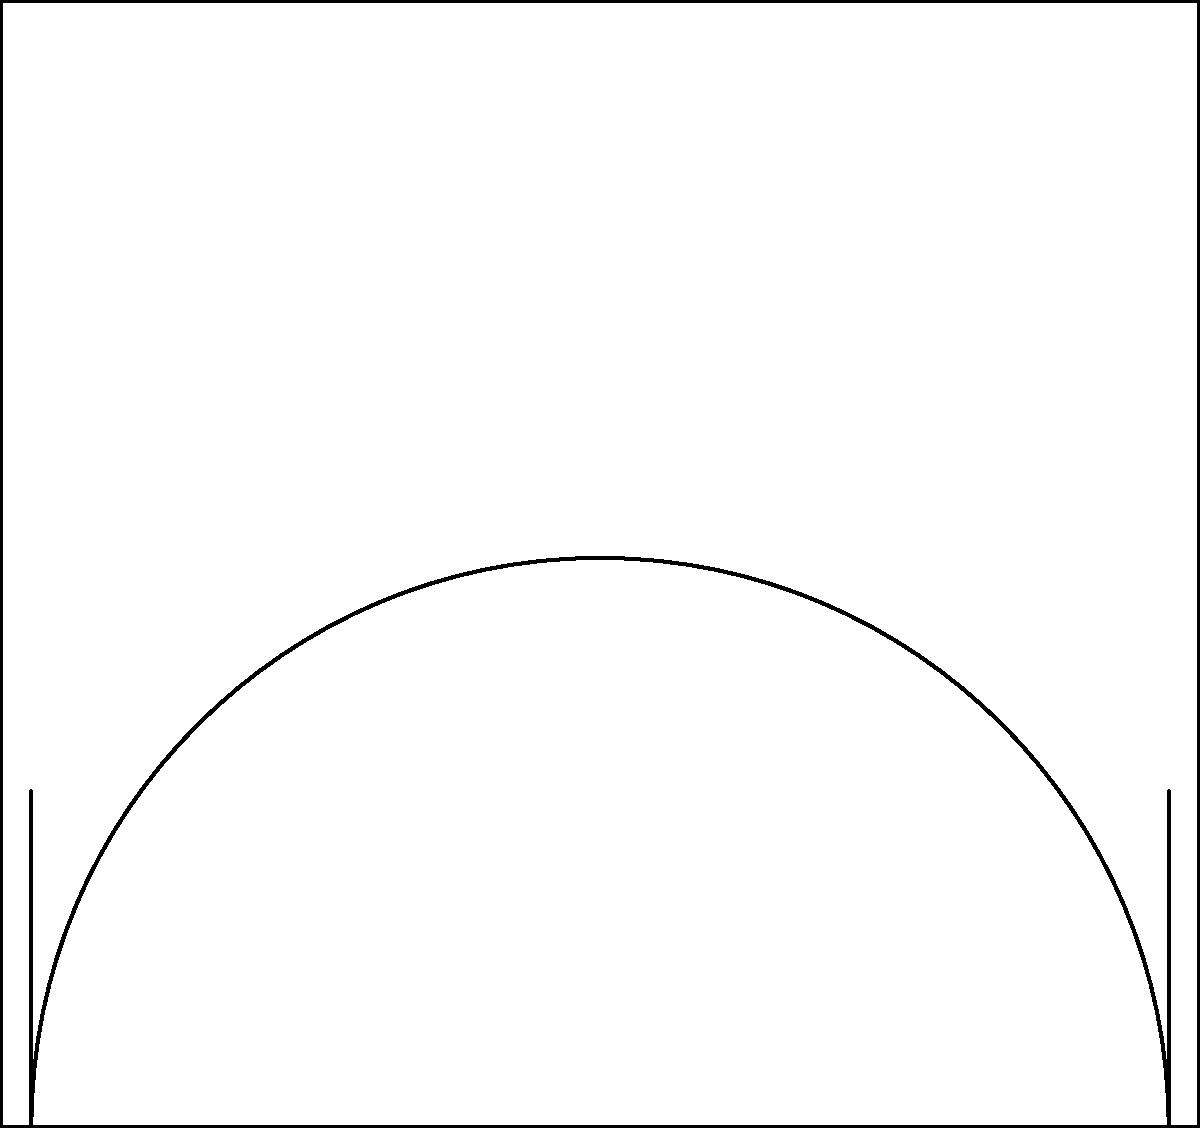Based on the shot accuracy heatmap of your child's basketball performance, which area of the court shows the highest accuracy, and what strategies would you recommend to improve overall shooting efficiency? To analyze the shot accuracy heatmap and develop strategies for improvement, let's follow these steps:

1. Interpret the heatmap:
   - The court is divided into a 5x5 grid.
   - Darker red areas indicate higher shot accuracy, while lighter areas show lower accuracy.

2. Identify the area with the highest accuracy:
   - The darkest red square is in the center of the heatmap.
   - This corresponds to the area just in front of the free-throw line.

3. Analyze the overall pattern:
   - Accuracy is generally higher in the middle of the court.
   - Accuracy decreases towards the corners and baseline.
   - The three-point line area shows lower accuracy compared to inside the arc.

4. Calculate shooting percentages:
   - Assume the darkest red (value 10) represents 100% accuracy.
   - The center square (value 10) = 100% accuracy
   - Corner squares (value 1) = 10% accuracy

5. Develop strategies for improvement:
   a) Focus on strengths:
      - Encourage more shots from the high-accuracy area (free-throw line).
      - Practice mid-range jump shots to capitalize on this strength.

   b) Address weaknesses:
      - Increase practice for three-point shots, especially from the corners.
      - Work on baseline jumpers to improve accuracy near the basket.

   c) Balanced approach:
      - Develop a well-rounded shooting ability by practicing from all areas.
      - Gradually increase the number of shots taken from lower-accuracy zones.

   d) Situational practice:
      - Simulate game situations that lead to shots from high-accuracy areas.
      - Practice quick release and shooting under pressure for all court positions.

   e) Track progress:
      - Regularly update the heatmap to monitor improvements.
      - Adjust the training regimen based on changes in the heatmap.

By implementing these strategies and continuously analyzing the heatmap data, you can help your child improve their overall shooting efficiency and become a more versatile basketball player.
Answer: Highest accuracy: free-throw line area. Strategies: Focus on mid-range shots, improve three-pointers and baseline jumpers, practice from all areas, simulate game situations, and track progress regularly. 